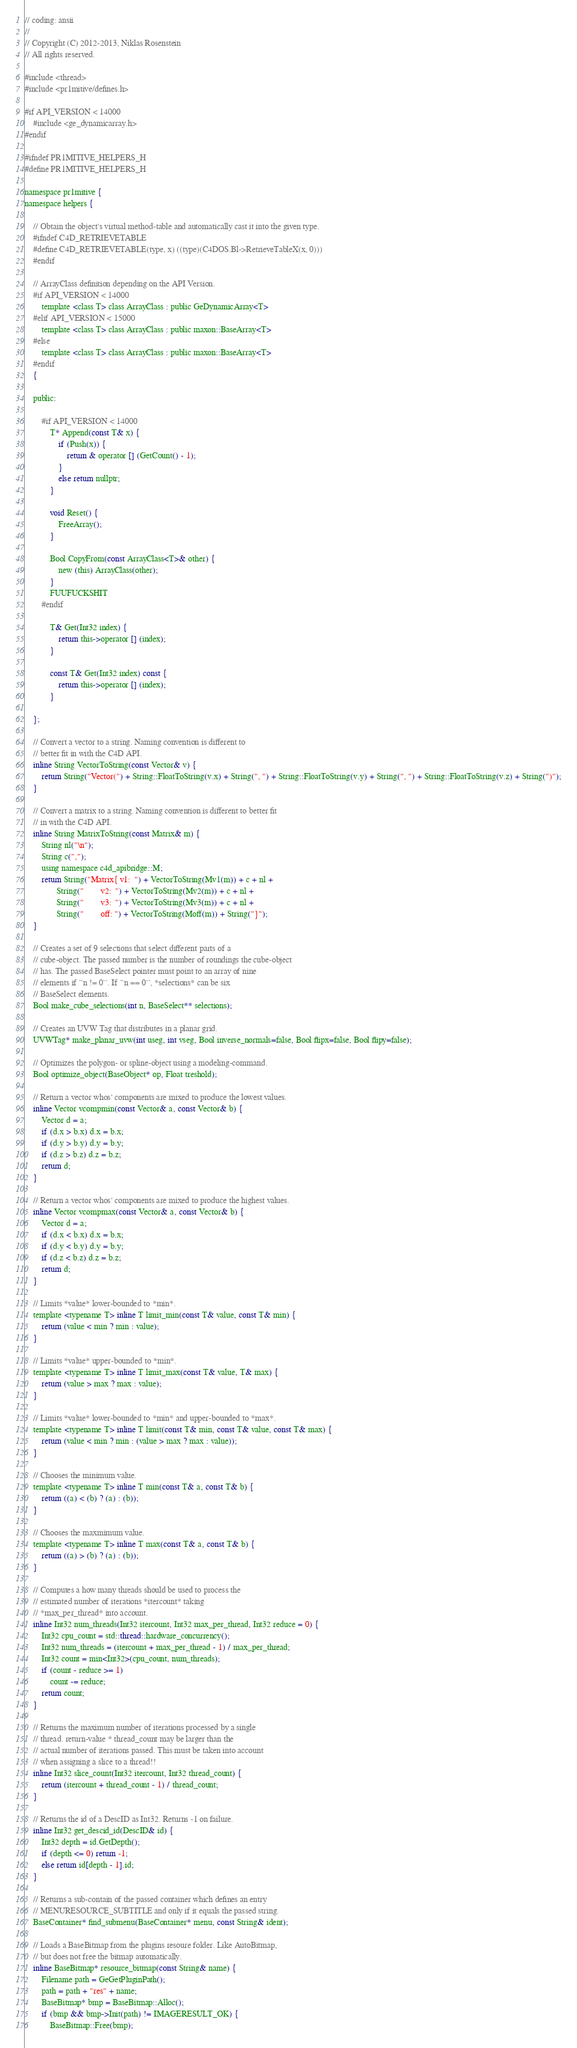<code> <loc_0><loc_0><loc_500><loc_500><_C_>// coding: ansii
//
// Copyright (C) 2012-2013, Niklas Rosenstein
// All rights reserved.

#include <thread>
#include <pr1mitive/defines.h>

#if API_VERSION < 14000
    #include <ge_dynamicarray.h>
#endif

#ifndef PR1MITIVE_HELPERS_H
#define PR1MITIVE_HELPERS_H

namespace pr1mitive {
namespace helpers {

    // Obtain the object's virtual method-table and automatically cast it into the given type.
    #ifndef C4D_RETRIEVETABLE
    #define C4D_RETRIEVETABLE(type, x) ((type)(C4DOS.Bl->RetrieveTableX(x, 0)))
    #endif

    // ArrayClass definition depending on the API Version.
    #if API_VERSION < 14000
        template <class T> class ArrayClass : public GeDynamicArray<T>
    #elif API_VERSION < 15000
        template <class T> class ArrayClass : public maxon::BaseArray<T>
    #else
        template <class T> class ArrayClass : public maxon::BaseArray<T>
    #endif
    {

    public:

        #if API_VERSION < 14000
            T* Append(const T& x) {
                if (Push(x)) {
                    return & operator [] (GetCount() - 1);
                }
                else return nullptr;
            }

            void Reset() {
                FreeArray();
            }

            Bool CopyFrom(const ArrayClass<T>& other) {
                new (this) ArrayClass(other);
            }
            FUUFUCKSHIT
        #endif

            T& Get(Int32 index) {
                return this->operator [] (index);
            }

            const T& Get(Int32 index) const {
                return this->operator [] (index);
            }

    };

    // Convert a vector to a string. Naming convention is different to
    // better fit in with the C4D API.
    inline String VectorToString(const Vector& v) {
        return String("Vector(") + String::FloatToString(v.x) + String(", ") + String::FloatToString(v.y) + String(", ") + String::FloatToString(v.z) + String(")");
    }

    // Convert a matrix to a string. Naming convention is different to better fit
    // in with the C4D API.
    inline String MatrixToString(const Matrix& m) {
        String nl("\n");
        String c(",");
        using namespace c4d_apibridge::M;
        return String("Matrix{ v1:  ") + VectorToString(Mv1(m)) + c + nl +
               String("        v2:  ") + VectorToString(Mv2(m)) + c + nl +
               String("        v3:  ") + VectorToString(Mv3(m)) + c + nl +
               String("        off: ") + VectorToString(Moff(m)) + String("}");
    }

    // Creates a set of 9 selections that select different parts of a
    // cube-object. The passed number is the number of roundings the cube-object
    // has. The passed BaseSelect pointer must point to an array of nine
    // elements if ``n != 0``. If ``n == 0``, *selections* can be six
    // BaseSelect elements.
    Bool make_cube_selections(int n, BaseSelect** selections);

    // Creates an UVW Tag that distributes in a planar grid.
    UVWTag* make_planar_uvw(int useg, int vseg, Bool inverse_normals=false, Bool flipx=false, Bool flipy=false);

    // Optimizes the polygon- or spline-object using a modeling-command.
    Bool optimize_object(BaseObject* op, Float treshold);

    // Return a vector whos' components are mixed to produce the lowest values.
    inline Vector vcompmin(const Vector& a, const Vector& b) {
        Vector d = a;
        if (d.x > b.x) d.x = b.x;
        if (d.y > b.y) d.y = b.y;
        if (d.z > b.z) d.z = b.z;
        return d;
    }

    // Return a vector whos' components are mixed to produce the highest values.
    inline Vector vcompmax(const Vector& a, const Vector& b) {
        Vector d = a;
        if (d.x < b.x) d.x = b.x;
        if (d.y < b.y) d.y = b.y;
        if (d.z < b.z) d.z = b.z;
        return d;
    }

    // Limits *value* lower-bounded to *min*.
    template <typename T> inline T limit_min(const T& value, const T& min) {
        return (value < min ? min : value);
    }

    // Limits *value* upper-bounded to *min*.
    template <typename T> inline T limit_max(const T& value, T& max) {
        return (value > max ? max : value);
    }

    // Limits *value* lower-bounded to *min* and upper-bounded to *max*.
    template <typename T> inline T limit(const T& min, const T& value, const T& max) {
        return (value < min ? min : (value > max ? max : value));
    }

    // Chooses the minimum value.
    template <typename T> inline T min(const T& a, const T& b) {
        return ((a) < (b) ? (a) : (b));
    }

    // Chooses the maxmimum value.
    template <typename T> inline T max(const T& a, const T& b) {
        return ((a) > (b) ? (a) : (b));
    }

    // Computes a how many threads should be used to process the
    // estimated number of iterations *itercount* taking
    // *max_per_thread* into account.
    inline Int32 num_threads(Int32 itercount, Int32 max_per_thread, Int32 reduce = 0) {
        Int32 cpu_count = std::thread::hardware_concurrency();
        Int32 num_threads = (itercount + max_per_thread - 1) / max_per_thread;
        Int32 count = min<Int32>(cpu_count, num_threads);
        if (count - reduce >= 1)
            count -= reduce;
        return count;
    }

    // Returns the maximum number of iterations processed by a single
    // thread. return-value * thread_count may be larger than the
    // actual number of iterations passed. This must be taken into account
    // when assigning a slice to a thread!!
    inline Int32 slice_count(Int32 itercount, Int32 thread_count) {
        return (itercount + thread_count - 1) / thread_count;
    }

    // Returns the id of a DescID as Int32. Returns -1 on failure.
    inline Int32 get_descid_id(DescID& id) {
        Int32 depth = id.GetDepth();
        if (depth <= 0) return -1;
        else return id[depth - 1].id;
    }

    // Returns a sub-contain of the passed container which defines an entry
    // MENURESOURCE_SUBTITLE and only if it equals the passed string.
    BaseContainer* find_submenu(BaseContainer* menu, const String& ident);

    // Loads a BaseBitmap from the plugins resoure folder. Like AutoBitmap,
    // but does not free the bitmap automatically.
    inline BaseBitmap* resource_bitmap(const String& name) {
        Filename path = GeGetPluginPath();
        path = path + "res" + name;
        BaseBitmap* bmp = BaseBitmap::Alloc();
        if (bmp && bmp->Init(path) != IMAGERESULT_OK) {
            BaseBitmap::Free(bmp);</code> 